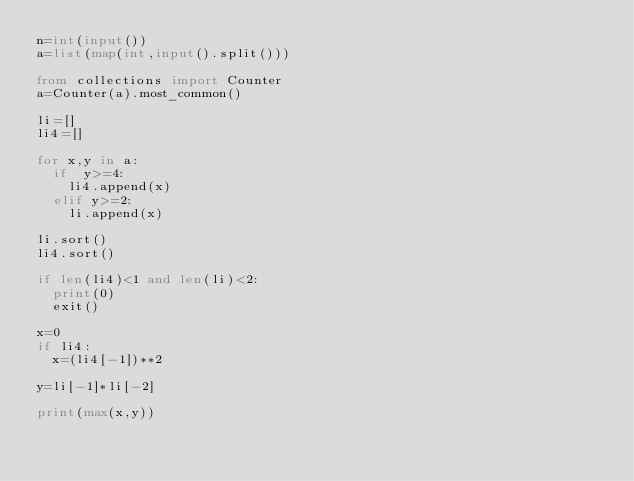<code> <loc_0><loc_0><loc_500><loc_500><_Python_>n=int(input())
a=list(map(int,input().split()))

from collections import Counter
a=Counter(a).most_common()

li=[]
li4=[]

for x,y in a:
  if  y>=4:
    li4.append(x)
  elif y>=2:
    li.append(x)

li.sort()
li4.sort()

if len(li4)<1 and len(li)<2:
  print(0)
  exit()

x=0
if li4:
  x=(li4[-1])**2

y=li[-1]*li[-2]

print(max(x,y))</code> 